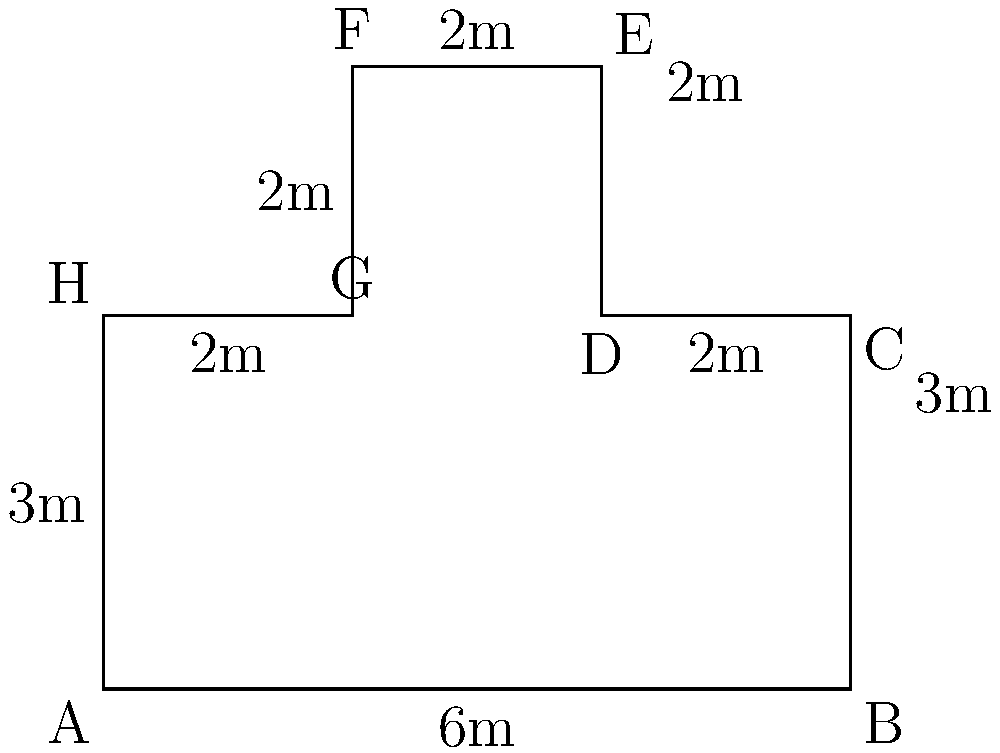An irregularly shaped examination room in a medical facility is represented by the polygon ABCDEFGH. Given the measurements shown in the diagram, calculate the total area of the examination room in square meters. To calculate the area of this irregular polygon, we can divide it into rectangles and then sum their areas:

1. Rectangle ABCH:
   Area = 6m × 3m = 18 m²

2. Rectangle CDEF:
   Area = 2m × 5m = 10 m²

3. Rectangle FGH:
   Area = 2m × 3m = 6 m²

Total area = Sum of all rectangle areas
$$\text{Total Area} = 18 \text{ m}^2 + 10 \text{ m}^2 + 6 \text{ m}^2 = 34 \text{ m}^2$$

Therefore, the total area of the examination room is 34 square meters.
Answer: 34 m² 